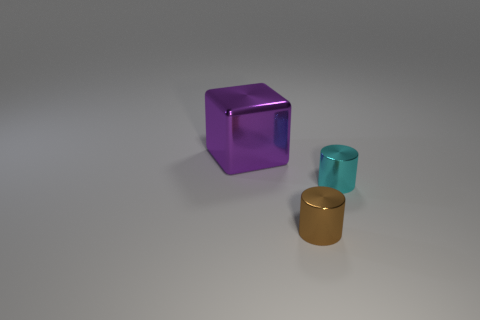What material is the brown cylinder that is the same size as the cyan thing?
Give a very brief answer. Metal. There is a small cylinder behind the small brown cylinder; does it have the same color as the metallic thing on the left side of the tiny brown metallic cylinder?
Your answer should be very brief. No. There is a tiny metal thing that is in front of the small cyan object; is there a tiny metal thing that is right of it?
Your answer should be very brief. Yes. There is a metal object that is right of the small brown metallic thing; is its shape the same as the tiny object left of the cyan metal object?
Give a very brief answer. Yes. Does the thing behind the cyan metallic thing have the same material as the object that is right of the tiny brown cylinder?
Your answer should be very brief. Yes. There is a small cylinder that is behind the cylinder that is in front of the cyan shiny object; what is its material?
Provide a short and direct response. Metal. There is a tiny object that is behind the small metallic cylinder in front of the object to the right of the tiny brown object; what shape is it?
Your answer should be very brief. Cylinder. There is another thing that is the same shape as the brown thing; what is its material?
Offer a very short reply. Metal. How many big blue spheres are there?
Provide a short and direct response. 0. What is the shape of the shiny thing on the left side of the brown metal cylinder?
Offer a terse response. Cube. 